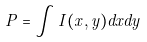<formula> <loc_0><loc_0><loc_500><loc_500>P = \int I ( x , y ) d x d y</formula> 